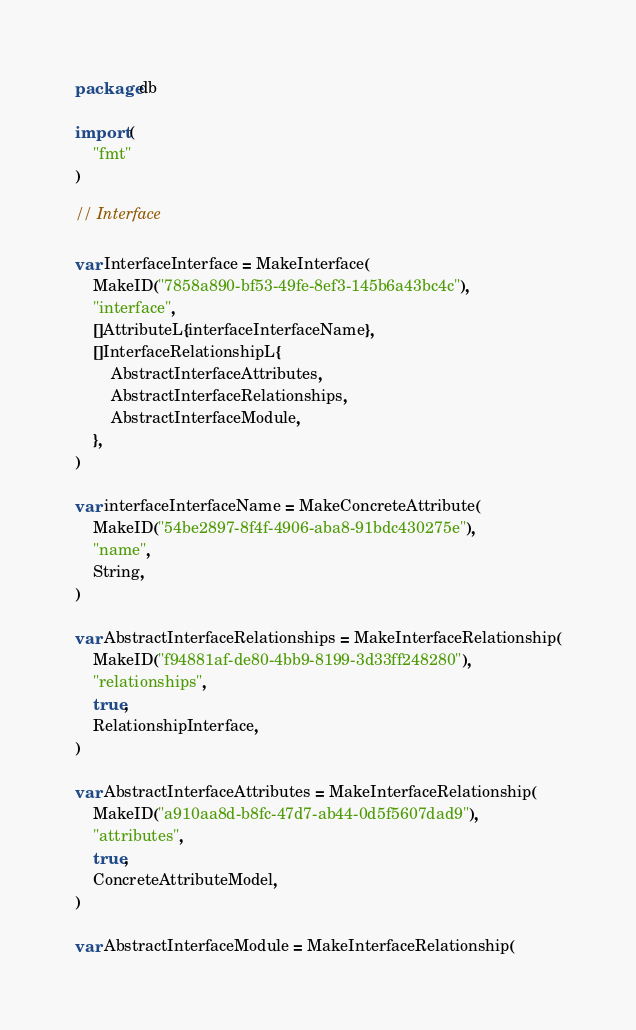<code> <loc_0><loc_0><loc_500><loc_500><_Go_>package db

import (
	"fmt"
)

// Interface

var InterfaceInterface = MakeInterface(
	MakeID("7858a890-bf53-49fe-8ef3-145b6a43bc4c"),
	"interface",
	[]AttributeL{interfaceInterfaceName},
	[]InterfaceRelationshipL{
		AbstractInterfaceAttributes,
		AbstractInterfaceRelationships,
		AbstractInterfaceModule,
	},
)

var interfaceInterfaceName = MakeConcreteAttribute(
	MakeID("54be2897-8f4f-4906-aba8-91bdc430275e"),
	"name",
	String,
)

var AbstractInterfaceRelationships = MakeInterfaceRelationship(
	MakeID("f94881af-de80-4bb9-8199-3d33ff248280"),
	"relationships",
	true,
	RelationshipInterface,
)

var AbstractInterfaceAttributes = MakeInterfaceRelationship(
	MakeID("a910aa8d-b8fc-47d7-ab44-0d5f5607dad9"),
	"attributes",
	true,
	ConcreteAttributeModel,
)

var AbstractInterfaceModule = MakeInterfaceRelationship(</code> 